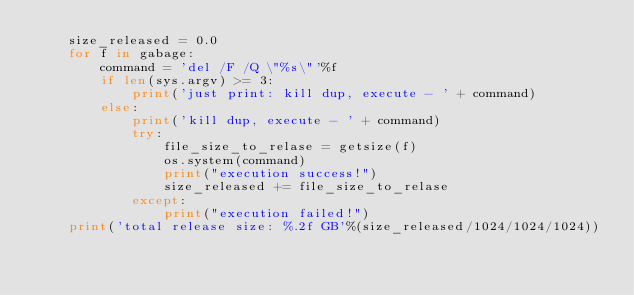<code> <loc_0><loc_0><loc_500><loc_500><_Python_>    size_released = 0.0
    for f in gabage:
        command = 'del /F /Q \"%s\"'%f
        if len(sys.argv) >= 3:
            print('just print: kill dup, execute - ' + command)
        else:
            print('kill dup, execute - ' + command)
            try:
                file_size_to_relase = getsize(f)
                os.system(command)
                print("execution success!")
                size_released += file_size_to_relase
            except:
                print("execution failed!")
    print('total release size: %.2f GB'%(size_released/1024/1024/1024))
</code> 